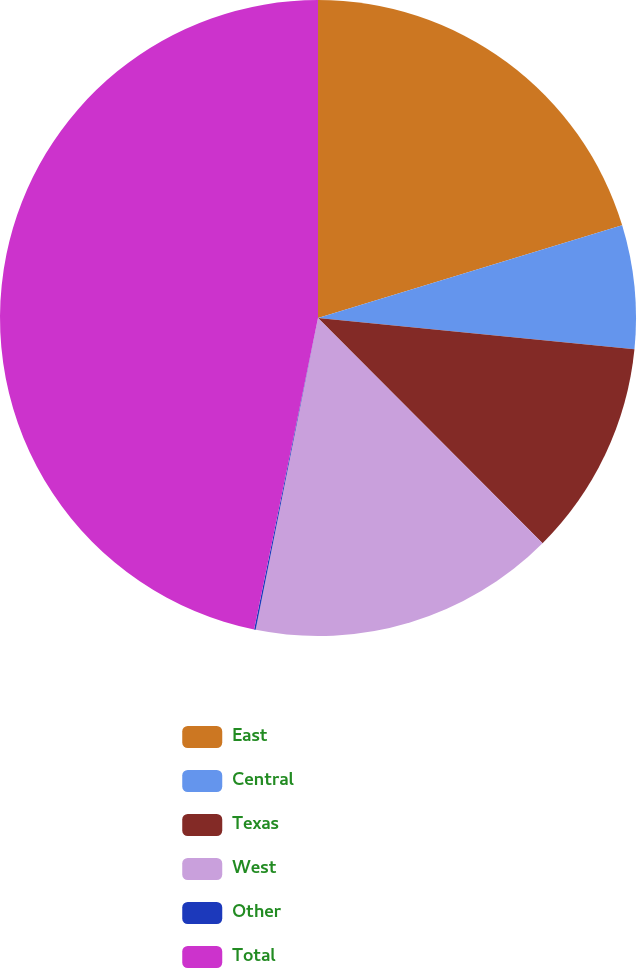Convert chart. <chart><loc_0><loc_0><loc_500><loc_500><pie_chart><fcel>East<fcel>Central<fcel>Texas<fcel>West<fcel>Other<fcel>Total<nl><fcel>20.29%<fcel>6.28%<fcel>10.95%<fcel>15.62%<fcel>0.08%<fcel>46.78%<nl></chart> 